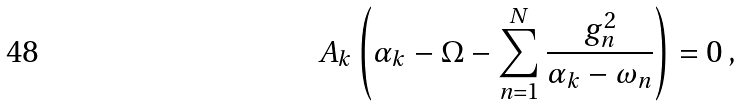Convert formula to latex. <formula><loc_0><loc_0><loc_500><loc_500>A _ { k } \left ( \alpha _ { k } - \Omega - \sum _ { n = 1 } ^ { N } \frac { g _ { n } ^ { 2 } } { \alpha _ { k } - \omega _ { n } } \right ) = 0 \, ,</formula> 